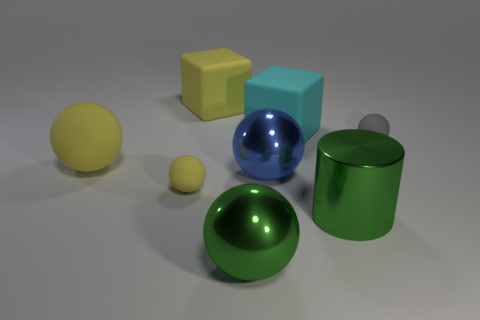Subtract all gray spheres. How many spheres are left? 4 Subtract all small gray matte spheres. How many spheres are left? 4 Subtract all cyan spheres. Subtract all cyan cylinders. How many spheres are left? 5 Add 1 large blue spheres. How many objects exist? 9 Subtract all cylinders. How many objects are left? 7 Subtract all tiny yellow spheres. Subtract all tiny matte things. How many objects are left? 5 Add 8 big metallic cylinders. How many big metallic cylinders are left? 9 Add 3 tiny blue rubber things. How many tiny blue rubber things exist? 3 Subtract 0 purple cubes. How many objects are left? 8 